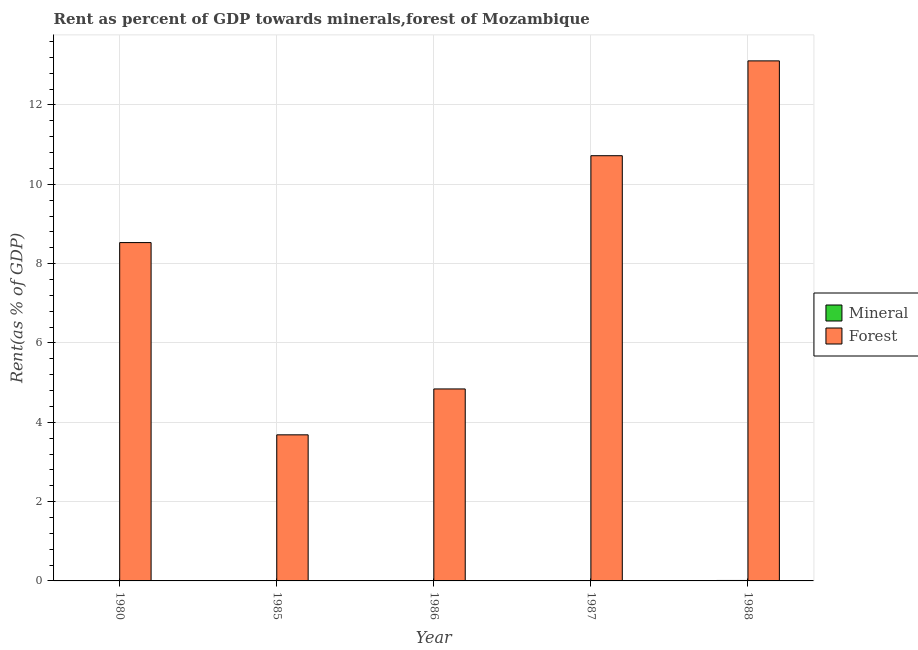Are the number of bars per tick equal to the number of legend labels?
Offer a very short reply. Yes. Are the number of bars on each tick of the X-axis equal?
Offer a very short reply. Yes. How many bars are there on the 2nd tick from the left?
Ensure brevity in your answer.  2. How many bars are there on the 1st tick from the right?
Offer a terse response. 2. What is the label of the 3rd group of bars from the left?
Your response must be concise. 1986. In how many cases, is the number of bars for a given year not equal to the number of legend labels?
Make the answer very short. 0. What is the mineral rent in 1985?
Keep it short and to the point. 0. Across all years, what is the maximum forest rent?
Ensure brevity in your answer.  13.11. Across all years, what is the minimum mineral rent?
Offer a terse response. 0. In which year was the mineral rent minimum?
Your answer should be very brief. 1986. What is the total forest rent in the graph?
Offer a very short reply. 40.89. What is the difference between the mineral rent in 1980 and that in 1986?
Make the answer very short. 0. What is the difference between the forest rent in 1988 and the mineral rent in 1987?
Provide a succinct answer. 2.39. What is the average forest rent per year?
Ensure brevity in your answer.  8.18. What is the ratio of the mineral rent in 1980 to that in 1988?
Offer a terse response. 0.53. Is the difference between the mineral rent in 1986 and 1988 greater than the difference between the forest rent in 1986 and 1988?
Provide a succinct answer. No. What is the difference between the highest and the second highest mineral rent?
Offer a very short reply. 0. What is the difference between the highest and the lowest forest rent?
Give a very brief answer. 9.43. Is the sum of the mineral rent in 1980 and 1985 greater than the maximum forest rent across all years?
Your answer should be compact. No. What does the 2nd bar from the left in 1980 represents?
Keep it short and to the point. Forest. What does the 1st bar from the right in 1986 represents?
Your answer should be compact. Forest. How many bars are there?
Give a very brief answer. 10. Are all the bars in the graph horizontal?
Your answer should be very brief. No. What is the difference between two consecutive major ticks on the Y-axis?
Provide a succinct answer. 2. Does the graph contain any zero values?
Offer a terse response. No. How many legend labels are there?
Offer a terse response. 2. What is the title of the graph?
Keep it short and to the point. Rent as percent of GDP towards minerals,forest of Mozambique. What is the label or title of the X-axis?
Keep it short and to the point. Year. What is the label or title of the Y-axis?
Ensure brevity in your answer.  Rent(as % of GDP). What is the Rent(as % of GDP) in Mineral in 1980?
Provide a short and direct response. 0.01. What is the Rent(as % of GDP) in Forest in 1980?
Offer a terse response. 8.53. What is the Rent(as % of GDP) of Mineral in 1985?
Offer a terse response. 0. What is the Rent(as % of GDP) of Forest in 1985?
Offer a very short reply. 3.68. What is the Rent(as % of GDP) of Mineral in 1986?
Ensure brevity in your answer.  0. What is the Rent(as % of GDP) in Forest in 1986?
Your answer should be very brief. 4.84. What is the Rent(as % of GDP) of Mineral in 1987?
Your answer should be compact. 0.01. What is the Rent(as % of GDP) of Forest in 1987?
Provide a short and direct response. 10.72. What is the Rent(as % of GDP) of Mineral in 1988?
Keep it short and to the point. 0.01. What is the Rent(as % of GDP) in Forest in 1988?
Provide a short and direct response. 13.11. Across all years, what is the maximum Rent(as % of GDP) of Mineral?
Your response must be concise. 0.01. Across all years, what is the maximum Rent(as % of GDP) of Forest?
Provide a short and direct response. 13.11. Across all years, what is the minimum Rent(as % of GDP) in Mineral?
Provide a succinct answer. 0. Across all years, what is the minimum Rent(as % of GDP) of Forest?
Provide a succinct answer. 3.68. What is the total Rent(as % of GDP) of Mineral in the graph?
Keep it short and to the point. 0.03. What is the total Rent(as % of GDP) of Forest in the graph?
Your answer should be compact. 40.89. What is the difference between the Rent(as % of GDP) of Mineral in 1980 and that in 1985?
Give a very brief answer. 0. What is the difference between the Rent(as % of GDP) in Forest in 1980 and that in 1985?
Your answer should be compact. 4.85. What is the difference between the Rent(as % of GDP) in Mineral in 1980 and that in 1986?
Keep it short and to the point. 0. What is the difference between the Rent(as % of GDP) of Forest in 1980 and that in 1986?
Provide a short and direct response. 3.69. What is the difference between the Rent(as % of GDP) in Mineral in 1980 and that in 1987?
Ensure brevity in your answer.  -0. What is the difference between the Rent(as % of GDP) in Forest in 1980 and that in 1987?
Give a very brief answer. -2.19. What is the difference between the Rent(as % of GDP) of Mineral in 1980 and that in 1988?
Offer a terse response. -0.01. What is the difference between the Rent(as % of GDP) in Forest in 1980 and that in 1988?
Make the answer very short. -4.58. What is the difference between the Rent(as % of GDP) of Mineral in 1985 and that in 1986?
Your answer should be compact. 0. What is the difference between the Rent(as % of GDP) of Forest in 1985 and that in 1986?
Give a very brief answer. -1.16. What is the difference between the Rent(as % of GDP) of Mineral in 1985 and that in 1987?
Offer a very short reply. -0. What is the difference between the Rent(as % of GDP) in Forest in 1985 and that in 1987?
Give a very brief answer. -7.04. What is the difference between the Rent(as % of GDP) of Mineral in 1985 and that in 1988?
Offer a very short reply. -0.01. What is the difference between the Rent(as % of GDP) of Forest in 1985 and that in 1988?
Provide a short and direct response. -9.43. What is the difference between the Rent(as % of GDP) in Mineral in 1986 and that in 1987?
Provide a short and direct response. -0.01. What is the difference between the Rent(as % of GDP) of Forest in 1986 and that in 1987?
Keep it short and to the point. -5.88. What is the difference between the Rent(as % of GDP) in Mineral in 1986 and that in 1988?
Offer a very short reply. -0.01. What is the difference between the Rent(as % of GDP) of Forest in 1986 and that in 1988?
Ensure brevity in your answer.  -8.27. What is the difference between the Rent(as % of GDP) in Mineral in 1987 and that in 1988?
Keep it short and to the point. -0. What is the difference between the Rent(as % of GDP) of Forest in 1987 and that in 1988?
Make the answer very short. -2.39. What is the difference between the Rent(as % of GDP) in Mineral in 1980 and the Rent(as % of GDP) in Forest in 1985?
Provide a short and direct response. -3.68. What is the difference between the Rent(as % of GDP) in Mineral in 1980 and the Rent(as % of GDP) in Forest in 1986?
Provide a short and direct response. -4.83. What is the difference between the Rent(as % of GDP) of Mineral in 1980 and the Rent(as % of GDP) of Forest in 1987?
Provide a succinct answer. -10.71. What is the difference between the Rent(as % of GDP) of Mineral in 1980 and the Rent(as % of GDP) of Forest in 1988?
Provide a succinct answer. -13.11. What is the difference between the Rent(as % of GDP) of Mineral in 1985 and the Rent(as % of GDP) of Forest in 1986?
Your response must be concise. -4.84. What is the difference between the Rent(as % of GDP) in Mineral in 1985 and the Rent(as % of GDP) in Forest in 1987?
Provide a short and direct response. -10.72. What is the difference between the Rent(as % of GDP) of Mineral in 1985 and the Rent(as % of GDP) of Forest in 1988?
Offer a very short reply. -13.11. What is the difference between the Rent(as % of GDP) in Mineral in 1986 and the Rent(as % of GDP) in Forest in 1987?
Make the answer very short. -10.72. What is the difference between the Rent(as % of GDP) of Mineral in 1986 and the Rent(as % of GDP) of Forest in 1988?
Provide a short and direct response. -13.11. What is the difference between the Rent(as % of GDP) of Mineral in 1987 and the Rent(as % of GDP) of Forest in 1988?
Offer a very short reply. -13.1. What is the average Rent(as % of GDP) of Mineral per year?
Provide a short and direct response. 0.01. What is the average Rent(as % of GDP) of Forest per year?
Keep it short and to the point. 8.18. In the year 1980, what is the difference between the Rent(as % of GDP) in Mineral and Rent(as % of GDP) in Forest?
Ensure brevity in your answer.  -8.52. In the year 1985, what is the difference between the Rent(as % of GDP) of Mineral and Rent(as % of GDP) of Forest?
Ensure brevity in your answer.  -3.68. In the year 1986, what is the difference between the Rent(as % of GDP) of Mineral and Rent(as % of GDP) of Forest?
Your response must be concise. -4.84. In the year 1987, what is the difference between the Rent(as % of GDP) in Mineral and Rent(as % of GDP) in Forest?
Your answer should be very brief. -10.71. In the year 1988, what is the difference between the Rent(as % of GDP) in Mineral and Rent(as % of GDP) in Forest?
Keep it short and to the point. -13.1. What is the ratio of the Rent(as % of GDP) of Mineral in 1980 to that in 1985?
Make the answer very short. 1.62. What is the ratio of the Rent(as % of GDP) of Forest in 1980 to that in 1985?
Provide a short and direct response. 2.32. What is the ratio of the Rent(as % of GDP) in Mineral in 1980 to that in 1986?
Provide a succinct answer. 2.81. What is the ratio of the Rent(as % of GDP) of Forest in 1980 to that in 1986?
Provide a short and direct response. 1.76. What is the ratio of the Rent(as % of GDP) of Mineral in 1980 to that in 1987?
Offer a terse response. 0.77. What is the ratio of the Rent(as % of GDP) of Forest in 1980 to that in 1987?
Provide a short and direct response. 0.8. What is the ratio of the Rent(as % of GDP) in Mineral in 1980 to that in 1988?
Offer a very short reply. 0.53. What is the ratio of the Rent(as % of GDP) in Forest in 1980 to that in 1988?
Offer a terse response. 0.65. What is the ratio of the Rent(as % of GDP) in Mineral in 1985 to that in 1986?
Your response must be concise. 1.73. What is the ratio of the Rent(as % of GDP) in Forest in 1985 to that in 1986?
Ensure brevity in your answer.  0.76. What is the ratio of the Rent(as % of GDP) of Mineral in 1985 to that in 1987?
Offer a terse response. 0.48. What is the ratio of the Rent(as % of GDP) in Forest in 1985 to that in 1987?
Your response must be concise. 0.34. What is the ratio of the Rent(as % of GDP) in Mineral in 1985 to that in 1988?
Your response must be concise. 0.33. What is the ratio of the Rent(as % of GDP) of Forest in 1985 to that in 1988?
Your answer should be compact. 0.28. What is the ratio of the Rent(as % of GDP) of Mineral in 1986 to that in 1987?
Make the answer very short. 0.27. What is the ratio of the Rent(as % of GDP) of Forest in 1986 to that in 1987?
Offer a very short reply. 0.45. What is the ratio of the Rent(as % of GDP) of Mineral in 1986 to that in 1988?
Give a very brief answer. 0.19. What is the ratio of the Rent(as % of GDP) of Forest in 1986 to that in 1988?
Offer a terse response. 0.37. What is the ratio of the Rent(as % of GDP) in Mineral in 1987 to that in 1988?
Ensure brevity in your answer.  0.69. What is the ratio of the Rent(as % of GDP) in Forest in 1987 to that in 1988?
Give a very brief answer. 0.82. What is the difference between the highest and the second highest Rent(as % of GDP) of Mineral?
Give a very brief answer. 0. What is the difference between the highest and the second highest Rent(as % of GDP) of Forest?
Your answer should be very brief. 2.39. What is the difference between the highest and the lowest Rent(as % of GDP) of Mineral?
Offer a terse response. 0.01. What is the difference between the highest and the lowest Rent(as % of GDP) in Forest?
Provide a short and direct response. 9.43. 